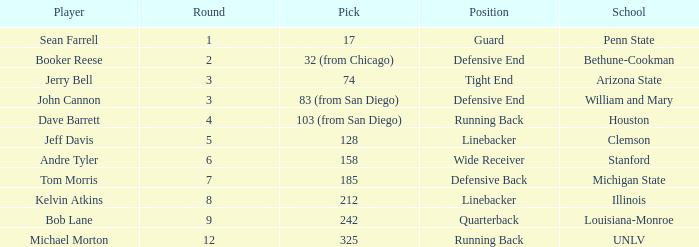Which school has a quarterback? Louisiana-Monroe. 